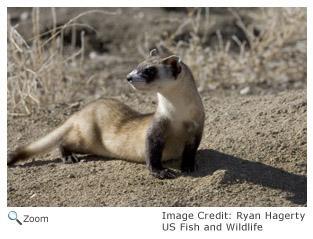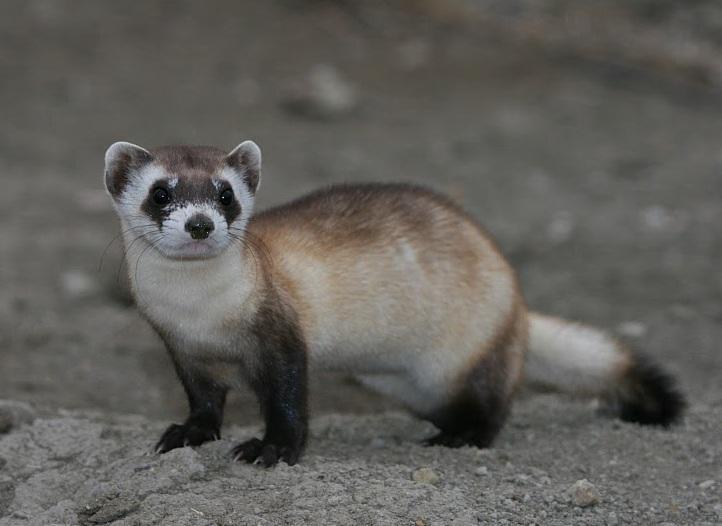The first image is the image on the left, the second image is the image on the right. Evaluate the accuracy of this statement regarding the images: "There are two black footed ferrets standing in the dirt in the center of the images.". Is it true? Answer yes or no. Yes. 